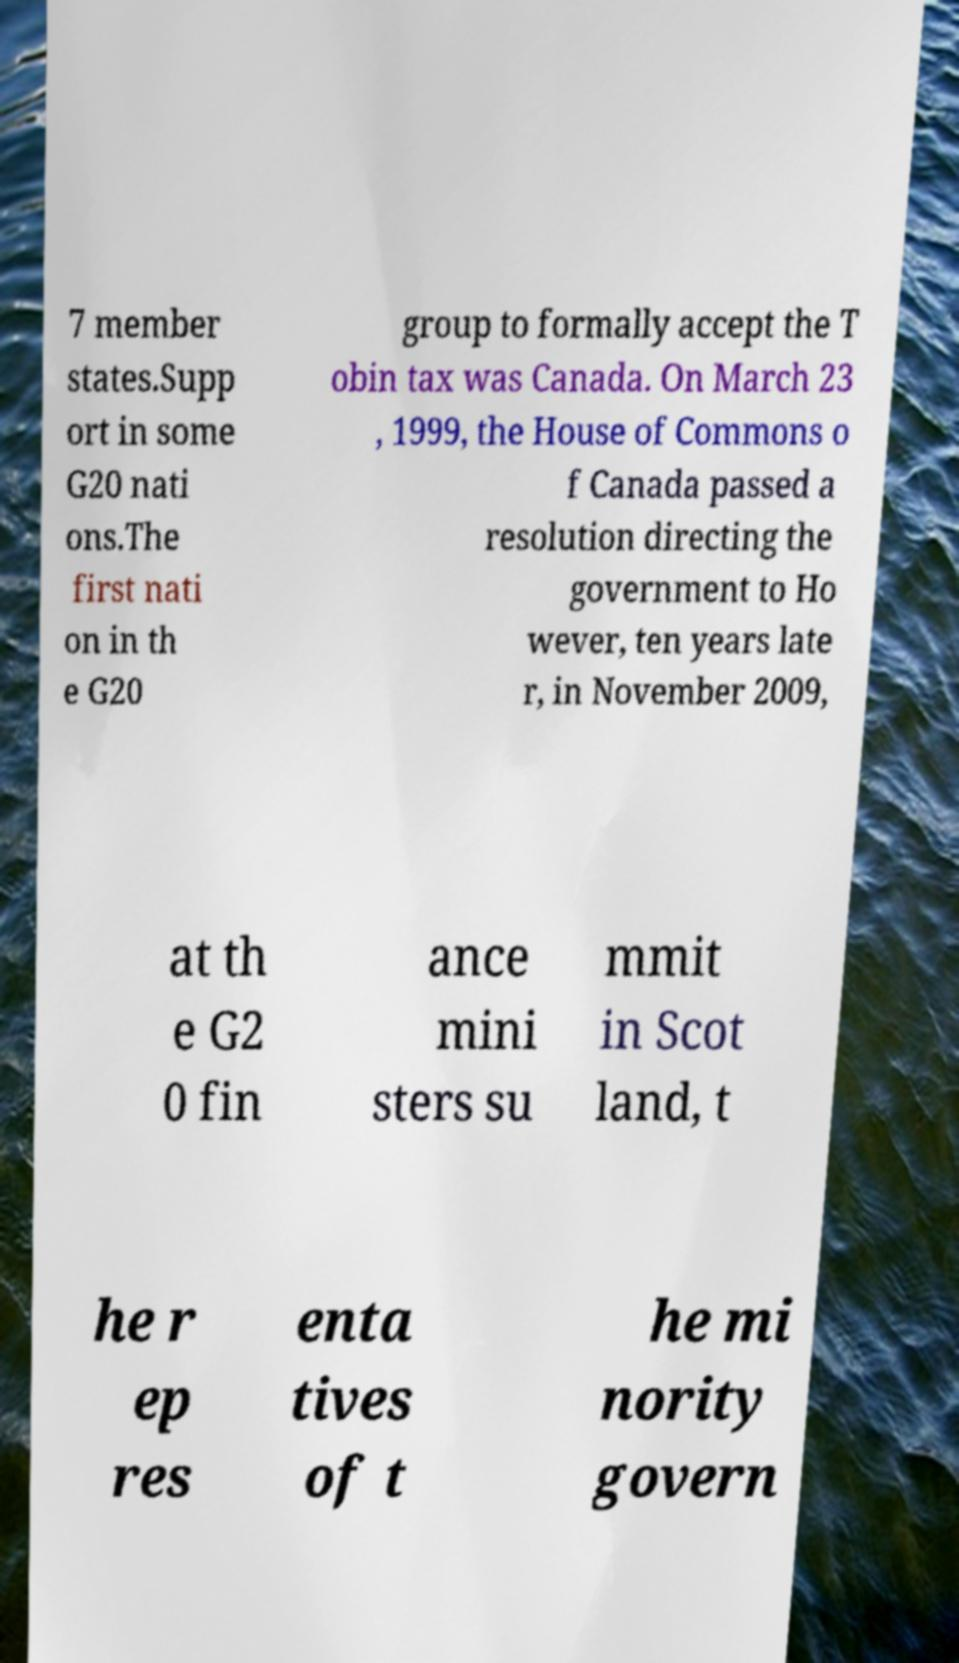Please read and relay the text visible in this image. What does it say? 7 member states.Supp ort in some G20 nati ons.The first nati on in th e G20 group to formally accept the T obin tax was Canada. On March 23 , 1999, the House of Commons o f Canada passed a resolution directing the government to Ho wever, ten years late r, in November 2009, at th e G2 0 fin ance mini sters su mmit in Scot land, t he r ep res enta tives of t he mi nority govern 